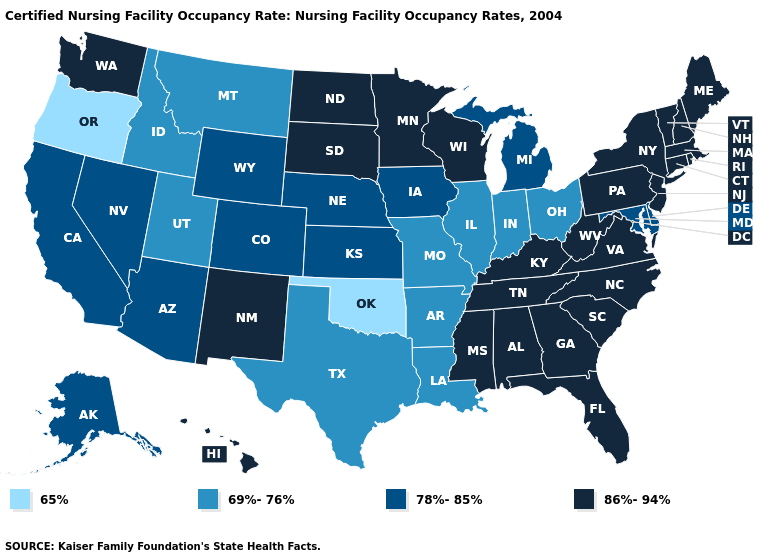Among the states that border Montana , which have the highest value?
Give a very brief answer. North Dakota, South Dakota. Among the states that border Indiana , does Kentucky have the highest value?
Be succinct. Yes. What is the highest value in states that border Oregon?
Concise answer only. 86%-94%. Name the states that have a value in the range 65%?
Keep it brief. Oklahoma, Oregon. What is the value of Oklahoma?
Write a very short answer. 65%. What is the value of Illinois?
Give a very brief answer. 69%-76%. Which states hav the highest value in the West?
Give a very brief answer. Hawaii, New Mexico, Washington. Name the states that have a value in the range 78%-85%?
Be succinct. Alaska, Arizona, California, Colorado, Delaware, Iowa, Kansas, Maryland, Michigan, Nebraska, Nevada, Wyoming. Which states have the highest value in the USA?
Keep it brief. Alabama, Connecticut, Florida, Georgia, Hawaii, Kentucky, Maine, Massachusetts, Minnesota, Mississippi, New Hampshire, New Jersey, New Mexico, New York, North Carolina, North Dakota, Pennsylvania, Rhode Island, South Carolina, South Dakota, Tennessee, Vermont, Virginia, Washington, West Virginia, Wisconsin. What is the value of Florida?
Be succinct. 86%-94%. Name the states that have a value in the range 78%-85%?
Quick response, please. Alaska, Arizona, California, Colorado, Delaware, Iowa, Kansas, Maryland, Michigan, Nebraska, Nevada, Wyoming. Name the states that have a value in the range 65%?
Answer briefly. Oklahoma, Oregon. Does the first symbol in the legend represent the smallest category?
Give a very brief answer. Yes. Name the states that have a value in the range 69%-76%?
Write a very short answer. Arkansas, Idaho, Illinois, Indiana, Louisiana, Missouri, Montana, Ohio, Texas, Utah. 